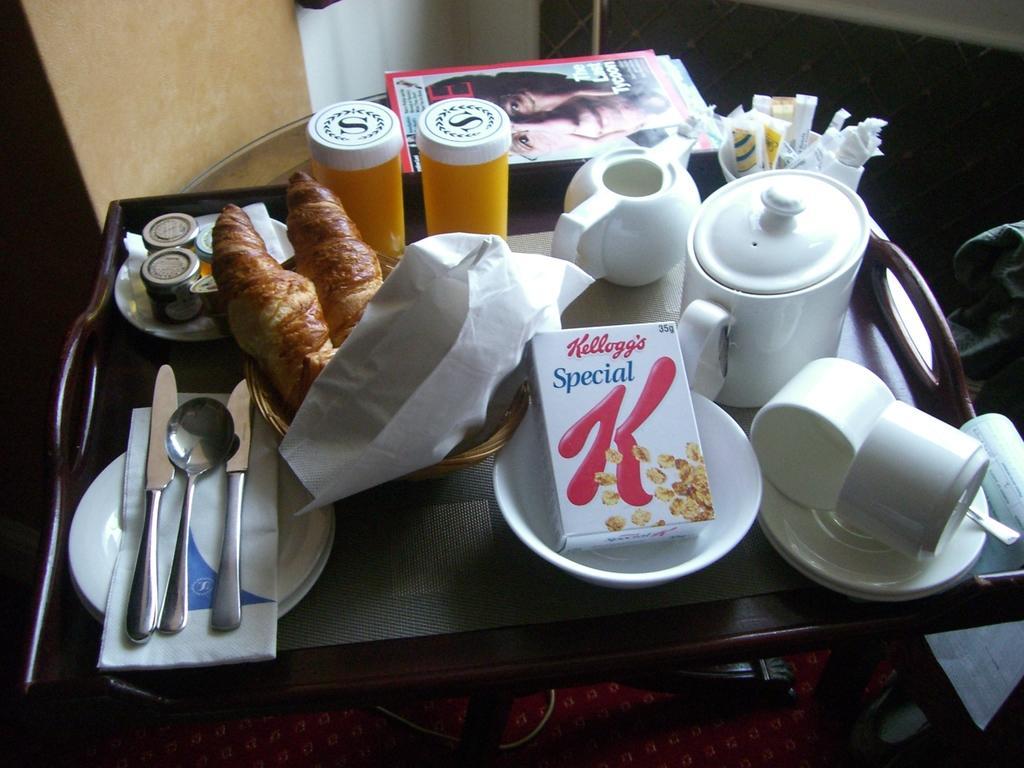In one or two sentences, can you explain what this image depicts? On the table I can see the pamphlet, book, knives, spoons, pots, jars, bowls, plates, tissue papers, bottles, steel box and other objects. At the top I can see the door and pillar. At the bottom I can see the red carpet on the floor. 